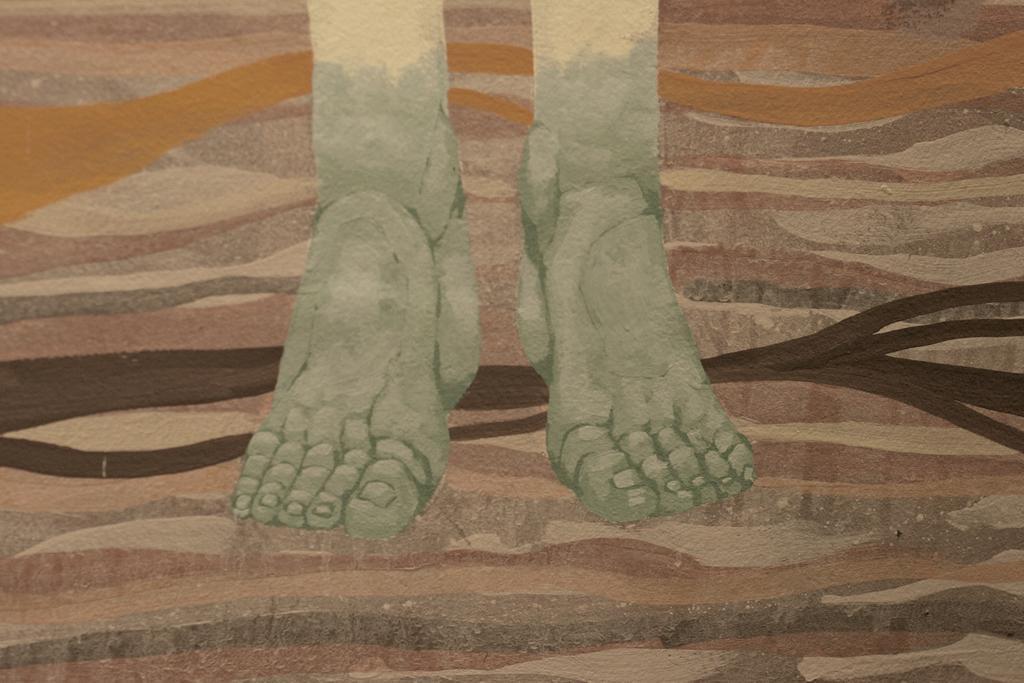Please provide a concise description of this image. In this image we can see a painting, in that we can see the legs of a person. 